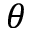Convert formula to latex. <formula><loc_0><loc_0><loc_500><loc_500>\theta</formula> 